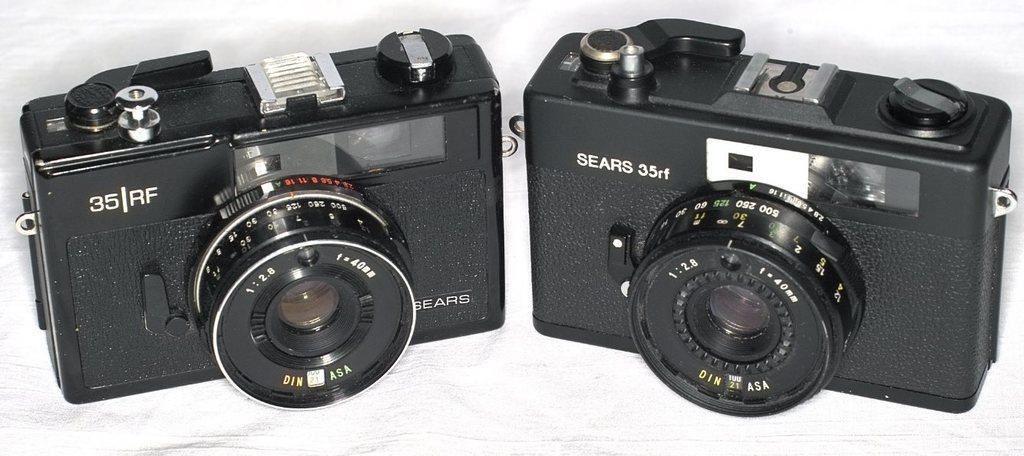What objects are present in the image? There are cameras in the image. Can you describe the cameras in the image? Unfortunately, the image does not provide enough detail to describe the cameras. What might the cameras be used for? The cameras might be used for photography, videography, or surveillance purposes. What type of scent can be detected from the cameras in the image? There is no scent associated with the cameras in the image, as cameras do not emit scents. 